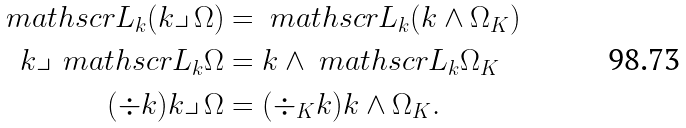<formula> <loc_0><loc_0><loc_500><loc_500>\ m a t h s c r { L } _ { k } ( k \lrcorner \, \Omega ) & = \ m a t h s c r { L } _ { k } ( k \wedge \Omega _ { K } ) \\ k \lrcorner \, \ m a t h s c r { L } _ { k } \Omega & = k \wedge \ m a t h s c r { L } _ { k } \Omega _ { K } \\ ( \div k ) k \lrcorner \, \Omega & = ( \div _ { K } k ) k \wedge \Omega _ { K } .</formula> 